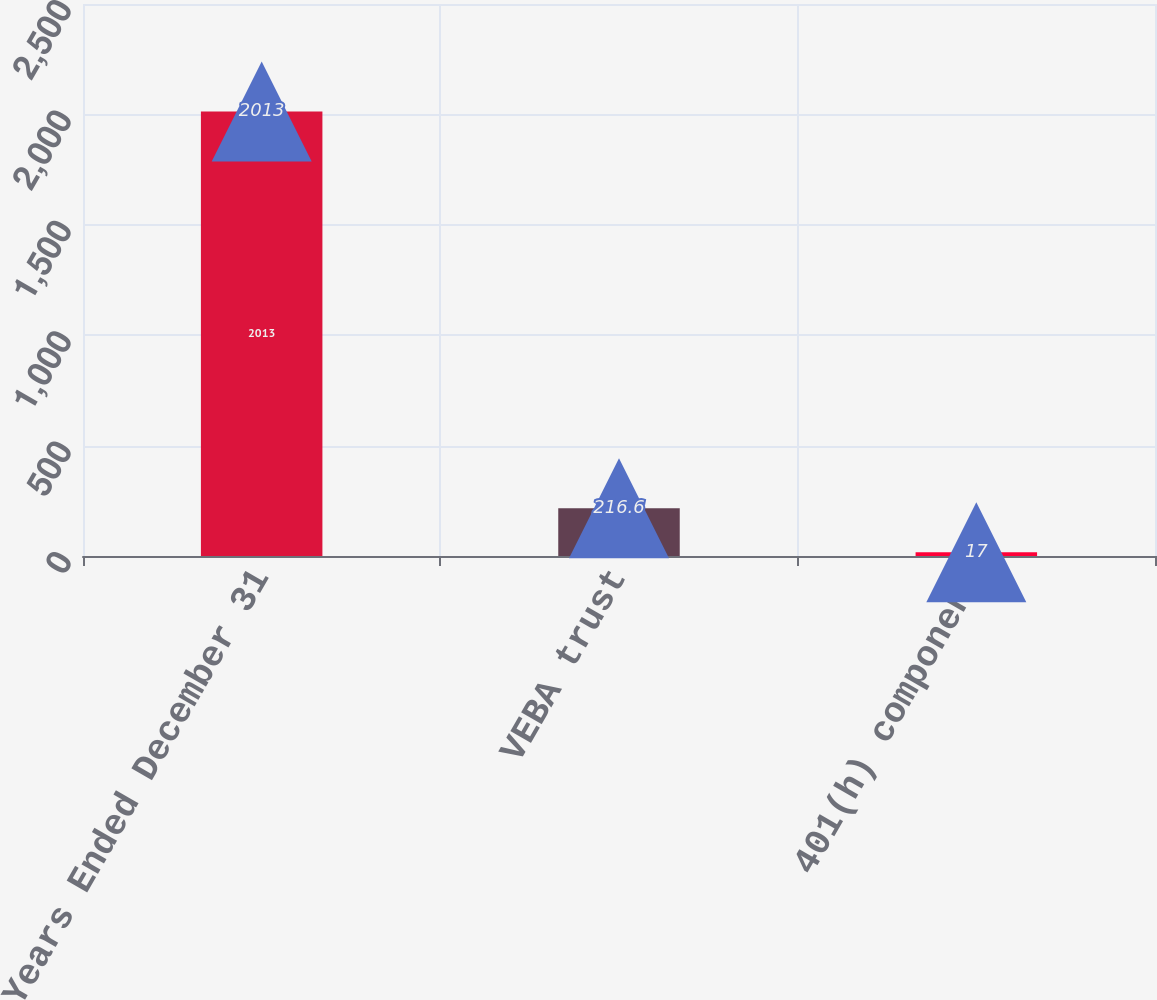<chart> <loc_0><loc_0><loc_500><loc_500><bar_chart><fcel>Years Ended December 31<fcel>VEBA trust<fcel>401(h) component<nl><fcel>2013<fcel>216.6<fcel>17<nl></chart> 